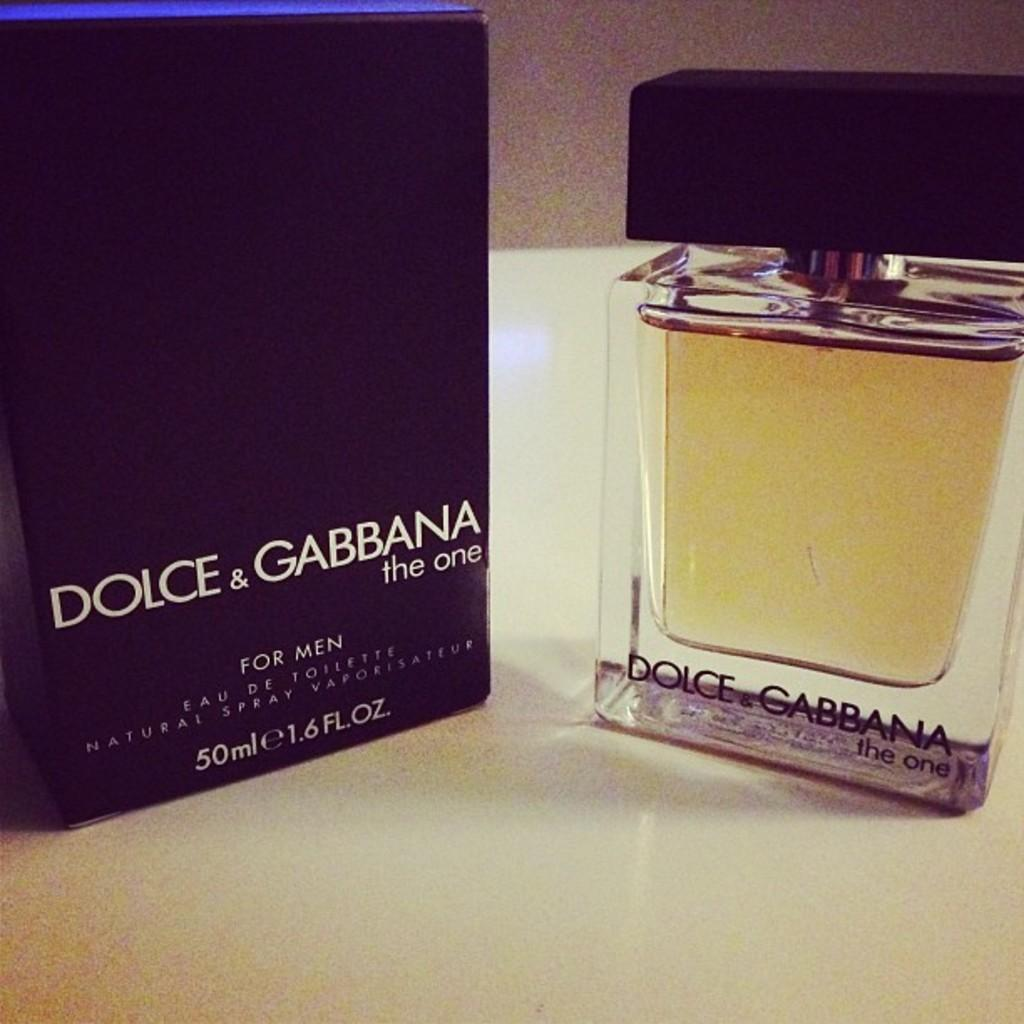<image>
Render a clear and concise summary of the photo. A Dolce & Gabbana fragrance is known as The One. 